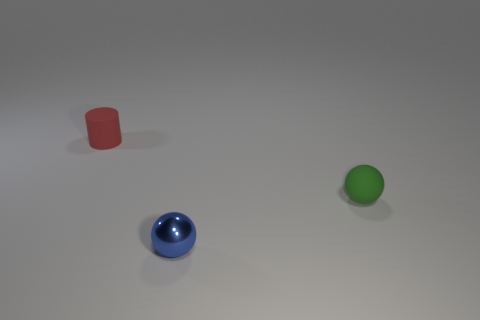Are there any other things that are the same material as the blue sphere?
Give a very brief answer. No. There is a thing that is both on the left side of the small green matte object and in front of the tiny red rubber object; what color is it?
Your answer should be compact. Blue. The green matte object that is the same shape as the small blue shiny thing is what size?
Offer a terse response. Small. How many other green matte spheres are the same size as the green rubber sphere?
Your answer should be very brief. 0. What is the blue thing made of?
Provide a succinct answer. Metal. Are there any objects behind the blue metallic sphere?
Provide a short and direct response. Yes. There is a cylinder that is made of the same material as the green sphere; what size is it?
Offer a very short reply. Small. What number of tiny rubber spheres are the same color as the shiny object?
Make the answer very short. 0. Are there fewer small blue metal things that are behind the green ball than things that are on the left side of the small shiny sphere?
Provide a short and direct response. Yes. There is a sphere that is in front of the small matte sphere; what size is it?
Your response must be concise. Small. 